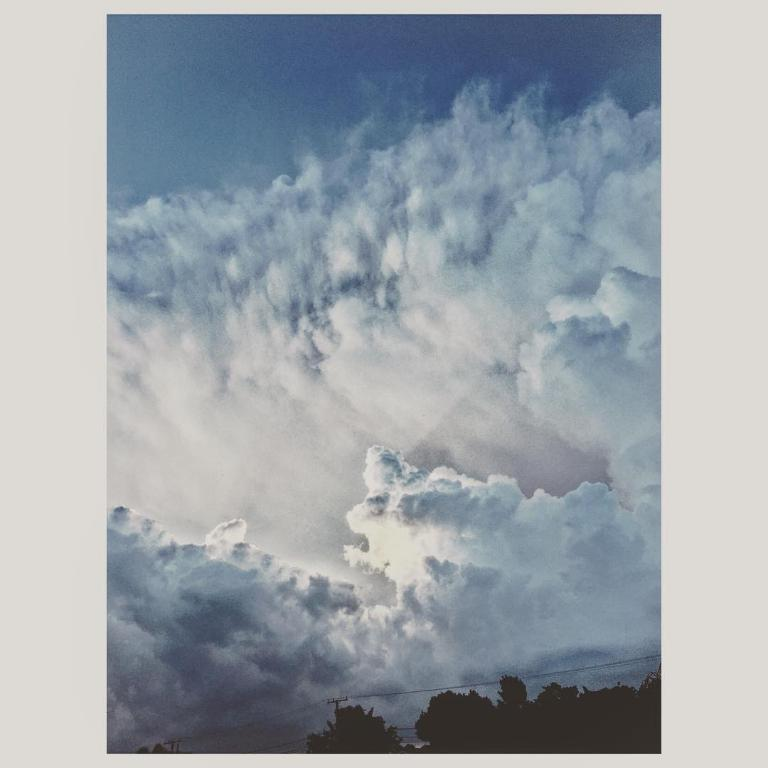What type of natural elements can be seen in the image? There are trees in the image. What man-made structures are present in the image? There are transmission towers in the image. What part of the natural environment is visible in the image? The sky is visible in the image. What atmospheric conditions can be observed in the sky? Clouds are present in the sky. How does the expert use the bridge to increase the efficiency of the transmission towers in the image? There is no expert, bridge, or indication of efficiency in the image; it features trees and transmission towers with clouds in the sky. 